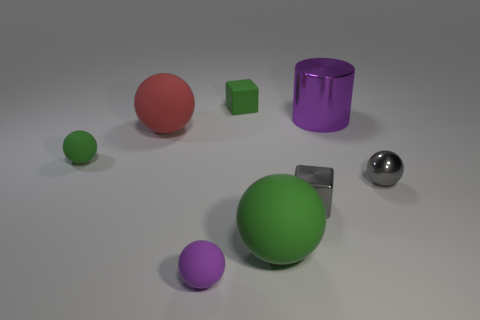Subtract all large green balls. How many balls are left? 4 Subtract all green blocks. How many green spheres are left? 2 Subtract 3 balls. How many balls are left? 2 Add 1 tiny spheres. How many objects exist? 9 Subtract all green spheres. How many spheres are left? 3 Add 6 small cyan metal balls. How many small cyan metal balls exist? 6 Subtract 0 yellow cylinders. How many objects are left? 8 Subtract all cubes. How many objects are left? 6 Subtract all yellow cubes. Subtract all yellow cylinders. How many cubes are left? 2 Subtract all tiny rubber objects. Subtract all cylinders. How many objects are left? 4 